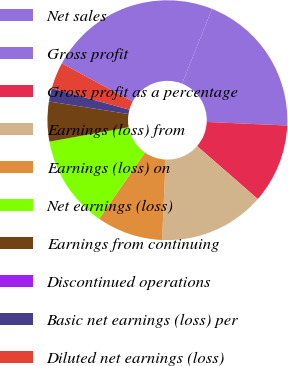<chart> <loc_0><loc_0><loc_500><loc_500><pie_chart><fcel>Net sales<fcel>Gross profit<fcel>Gross profit as a percentage<fcel>Earnings (loss) from<fcel>Earnings (loss) on<fcel>Net earnings (loss)<fcel>Earnings from continuing<fcel>Discontinued operations<fcel>Basic net earnings (loss) per<fcel>Diluted net earnings (loss)<nl><fcel>23.21%<fcel>19.64%<fcel>10.71%<fcel>14.29%<fcel>8.93%<fcel>12.5%<fcel>5.36%<fcel>0.0%<fcel>1.79%<fcel>3.57%<nl></chart> 